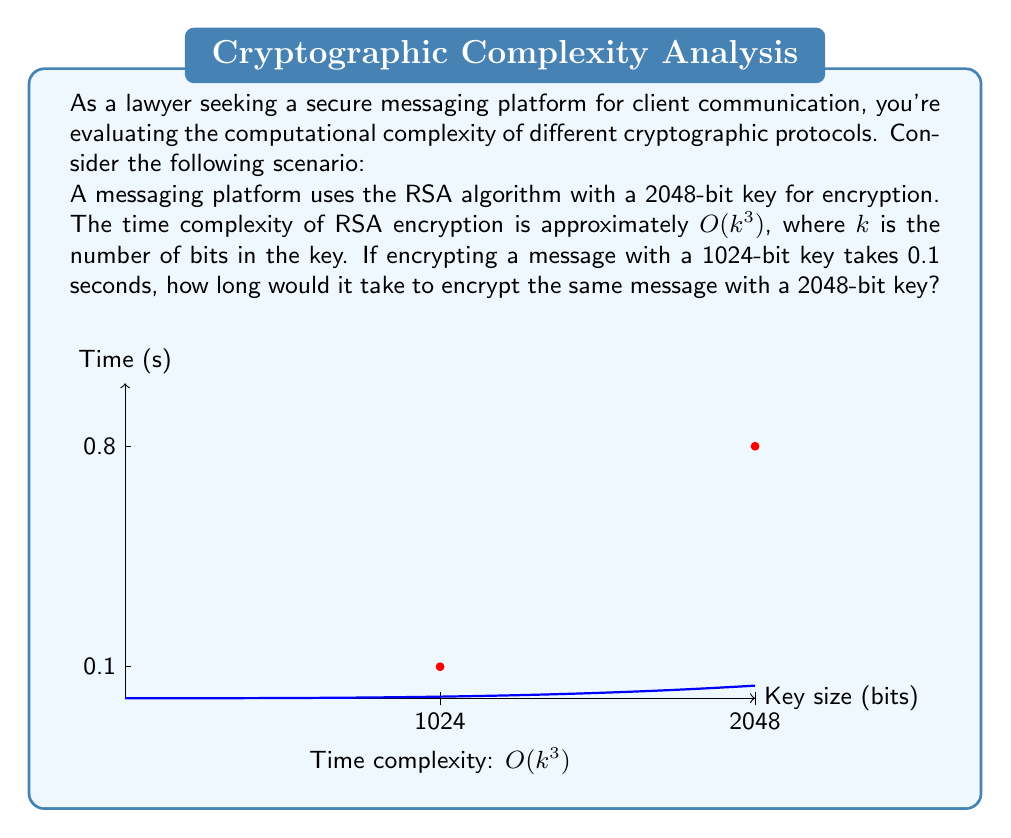Help me with this question. To solve this problem, we need to understand the relationship between key size and encryption time in RSA:

1) The time complexity of RSA is $O(k^3)$, where $k$ is the number of bits in the key.

2) We're given that encrypting with a 1024-bit key takes 0.1 seconds.

3) We need to find the time for a 2048-bit key.

4) Let's call the time for the 2048-bit key $t$. We can set up a proportion:

   $\frac{0.1}{1024^3} = \frac{t}{2048^3}$

5) Solving for $t$:

   $t = 0.1 \cdot \frac{2048^3}{1024^3}$

6) Simplify:
   
   $t = 0.1 \cdot \frac{2048^3}{1024^3} = 0.1 \cdot 8 = 0.8$

Therefore, it would take 0.8 seconds to encrypt the message with a 2048-bit key.

This demonstrates why longer keys, while providing more security, also require more computational resources and time.
Answer: 0.8 seconds 